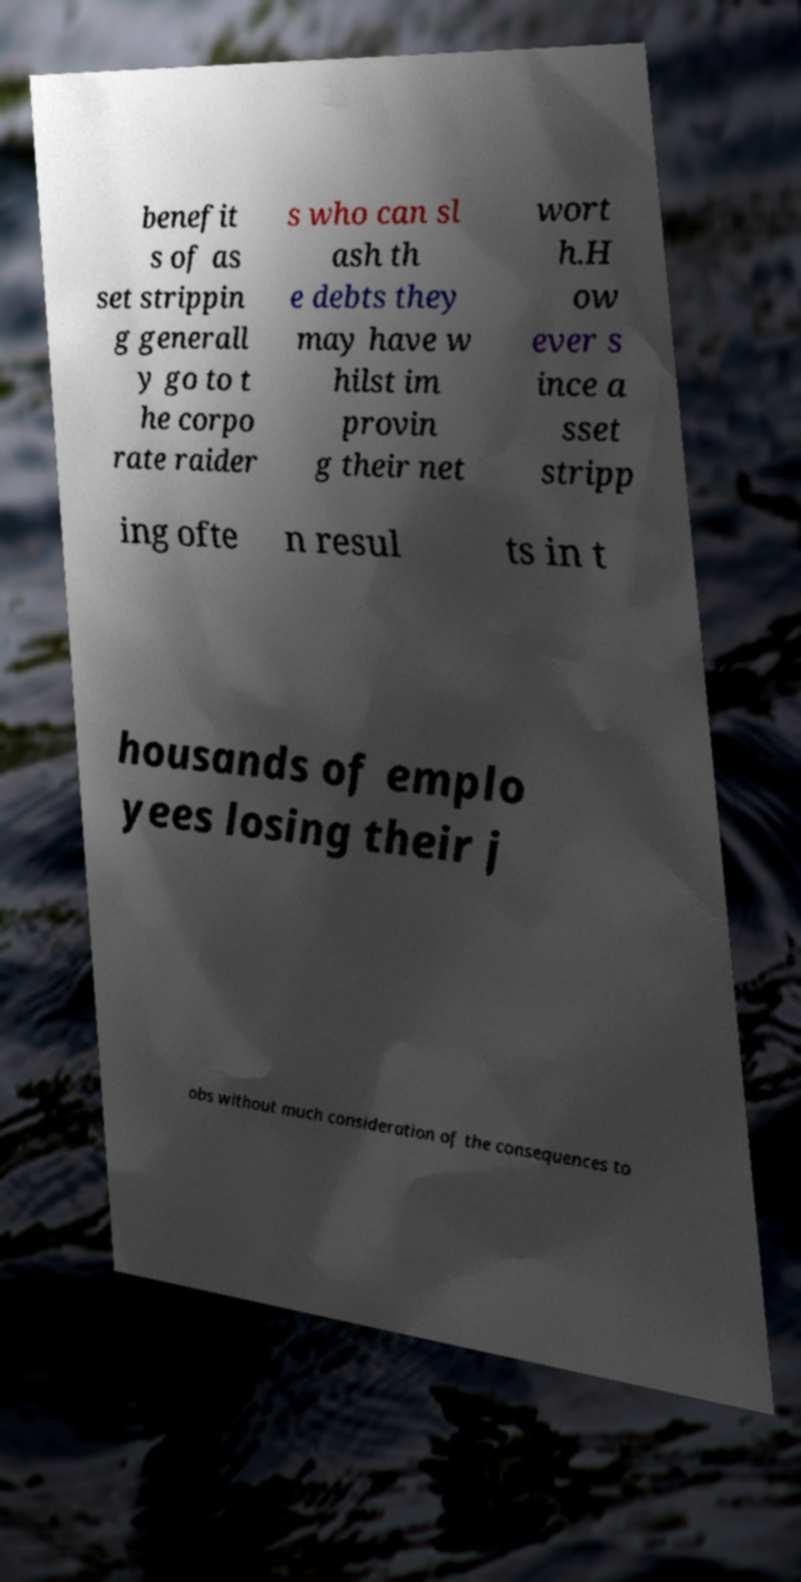Please read and relay the text visible in this image. What does it say? benefit s of as set strippin g generall y go to t he corpo rate raider s who can sl ash th e debts they may have w hilst im provin g their net wort h.H ow ever s ince a sset stripp ing ofte n resul ts in t housands of emplo yees losing their j obs without much consideration of the consequences to 